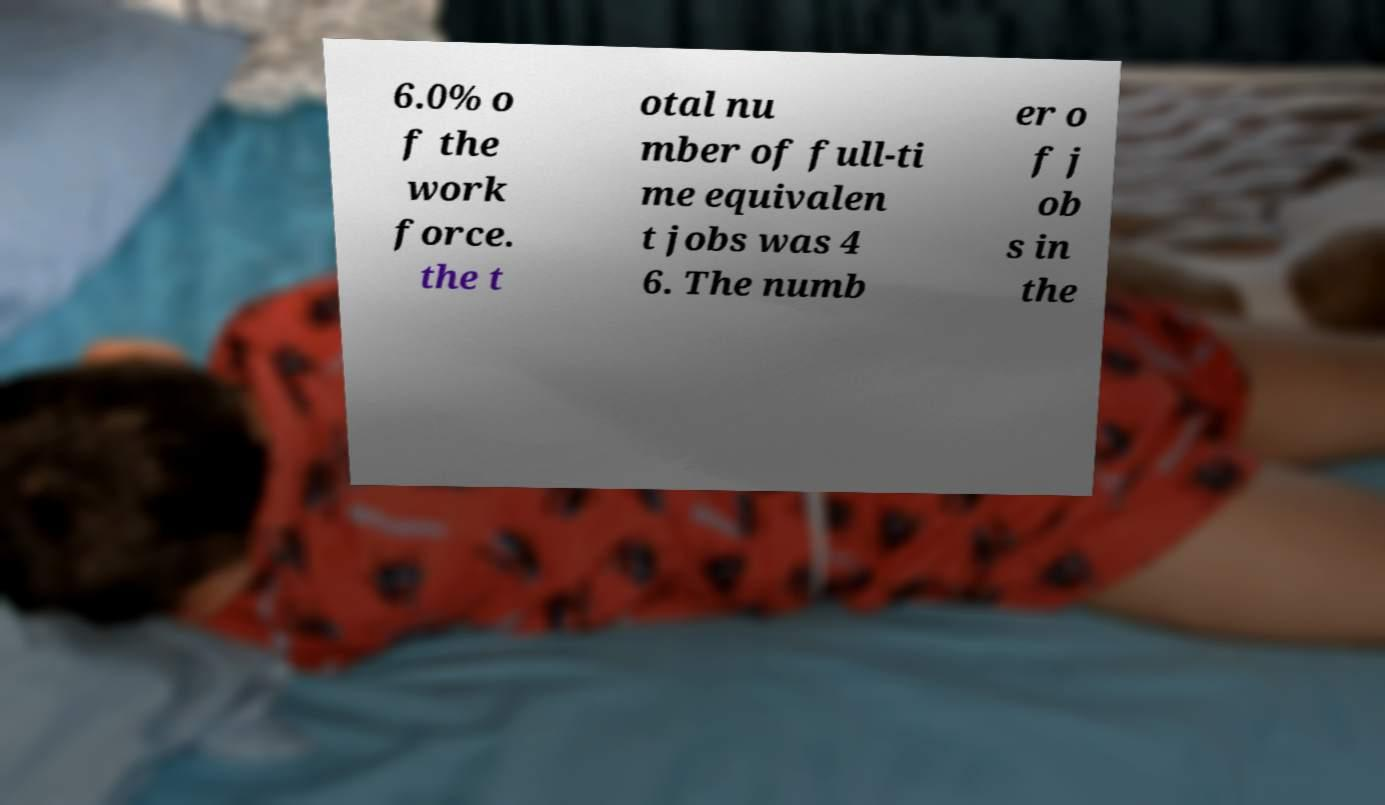What messages or text are displayed in this image? I need them in a readable, typed format. 6.0% o f the work force. the t otal nu mber of full-ti me equivalen t jobs was 4 6. The numb er o f j ob s in the 